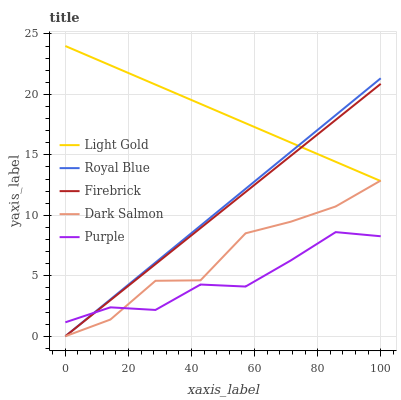Does Purple have the minimum area under the curve?
Answer yes or no. Yes. Does Light Gold have the maximum area under the curve?
Answer yes or no. Yes. Does Royal Blue have the minimum area under the curve?
Answer yes or no. No. Does Royal Blue have the maximum area under the curve?
Answer yes or no. No. Is Royal Blue the smoothest?
Answer yes or no. Yes. Is Dark Salmon the roughest?
Answer yes or no. Yes. Is Firebrick the smoothest?
Answer yes or no. No. Is Firebrick the roughest?
Answer yes or no. No. Does Royal Blue have the lowest value?
Answer yes or no. Yes. Does Light Gold have the lowest value?
Answer yes or no. No. Does Light Gold have the highest value?
Answer yes or no. Yes. Does Royal Blue have the highest value?
Answer yes or no. No. Is Purple less than Light Gold?
Answer yes or no. Yes. Is Light Gold greater than Purple?
Answer yes or no. Yes. Does Firebrick intersect Light Gold?
Answer yes or no. Yes. Is Firebrick less than Light Gold?
Answer yes or no. No. Is Firebrick greater than Light Gold?
Answer yes or no. No. Does Purple intersect Light Gold?
Answer yes or no. No. 